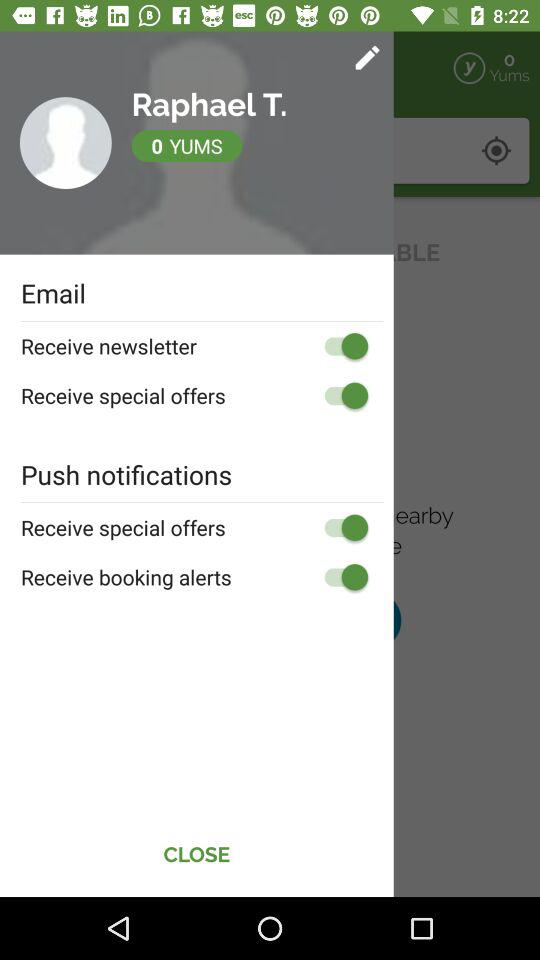What is the user name? The user name is Raphael T. 